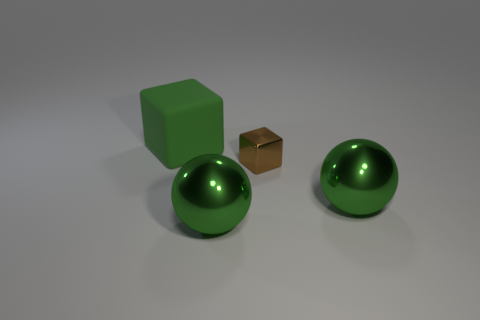What number of things are large green objects that are in front of the large matte cube or green metallic things on the left side of the small block?
Make the answer very short. 2. The big object that is in front of the metal object that is on the right side of the block to the right of the big green rubber cube is what shape?
Your response must be concise. Sphere. Is the number of big cubes that are in front of the green rubber block the same as the number of small blocks?
Make the answer very short. No. Is the size of the green matte object the same as the brown object?
Ensure brevity in your answer.  No. How many rubber objects are big blue cubes or tiny cubes?
Offer a terse response. 0. What number of other things are there of the same material as the tiny block
Ensure brevity in your answer.  2. Is the number of large green rubber cubes behind the tiny thing less than the number of gray cylinders?
Your answer should be compact. No. Is the small shiny object the same shape as the big green matte object?
Provide a succinct answer. Yes. There is a green object that is in front of the large green ball on the right side of the block that is in front of the large green matte object; how big is it?
Give a very brief answer. Large. There is a brown thing that is the same shape as the green matte object; what material is it?
Provide a short and direct response. Metal. 